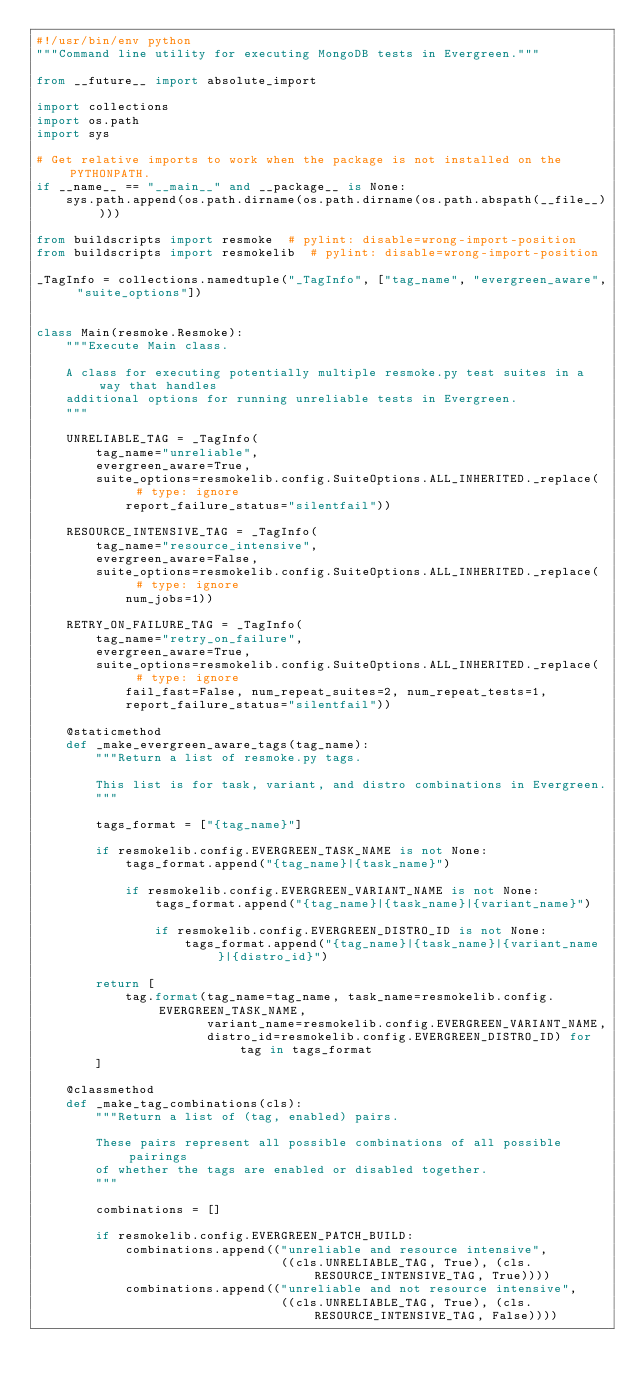<code> <loc_0><loc_0><loc_500><loc_500><_Python_>#!/usr/bin/env python
"""Command line utility for executing MongoDB tests in Evergreen."""

from __future__ import absolute_import

import collections
import os.path
import sys

# Get relative imports to work when the package is not installed on the PYTHONPATH.
if __name__ == "__main__" and __package__ is None:
    sys.path.append(os.path.dirname(os.path.dirname(os.path.abspath(__file__))))

from buildscripts import resmoke  # pylint: disable=wrong-import-position
from buildscripts import resmokelib  # pylint: disable=wrong-import-position

_TagInfo = collections.namedtuple("_TagInfo", ["tag_name", "evergreen_aware", "suite_options"])


class Main(resmoke.Resmoke):
    """Execute Main class.

    A class for executing potentially multiple resmoke.py test suites in a way that handles
    additional options for running unreliable tests in Evergreen.
    """

    UNRELIABLE_TAG = _TagInfo(
        tag_name="unreliable",
        evergreen_aware=True,
        suite_options=resmokelib.config.SuiteOptions.ALL_INHERITED._replace(  # type: ignore
            report_failure_status="silentfail"))

    RESOURCE_INTENSIVE_TAG = _TagInfo(
        tag_name="resource_intensive",
        evergreen_aware=False,
        suite_options=resmokelib.config.SuiteOptions.ALL_INHERITED._replace(  # type: ignore
            num_jobs=1))

    RETRY_ON_FAILURE_TAG = _TagInfo(
        tag_name="retry_on_failure",
        evergreen_aware=True,
        suite_options=resmokelib.config.SuiteOptions.ALL_INHERITED._replace(  # type: ignore
            fail_fast=False, num_repeat_suites=2, num_repeat_tests=1,
            report_failure_status="silentfail"))

    @staticmethod
    def _make_evergreen_aware_tags(tag_name):
        """Return a list of resmoke.py tags.

        This list is for task, variant, and distro combinations in Evergreen.
        """

        tags_format = ["{tag_name}"]

        if resmokelib.config.EVERGREEN_TASK_NAME is not None:
            tags_format.append("{tag_name}|{task_name}")

            if resmokelib.config.EVERGREEN_VARIANT_NAME is not None:
                tags_format.append("{tag_name}|{task_name}|{variant_name}")

                if resmokelib.config.EVERGREEN_DISTRO_ID is not None:
                    tags_format.append("{tag_name}|{task_name}|{variant_name}|{distro_id}")

        return [
            tag.format(tag_name=tag_name, task_name=resmokelib.config.EVERGREEN_TASK_NAME,
                       variant_name=resmokelib.config.EVERGREEN_VARIANT_NAME,
                       distro_id=resmokelib.config.EVERGREEN_DISTRO_ID) for tag in tags_format
        ]

    @classmethod
    def _make_tag_combinations(cls):
        """Return a list of (tag, enabled) pairs.

        These pairs represent all possible combinations of all possible pairings
        of whether the tags are enabled or disabled together.
        """

        combinations = []

        if resmokelib.config.EVERGREEN_PATCH_BUILD:
            combinations.append(("unreliable and resource intensive",
                                 ((cls.UNRELIABLE_TAG, True), (cls.RESOURCE_INTENSIVE_TAG, True))))
            combinations.append(("unreliable and not resource intensive",
                                 ((cls.UNRELIABLE_TAG, True), (cls.RESOURCE_INTENSIVE_TAG, False))))</code> 